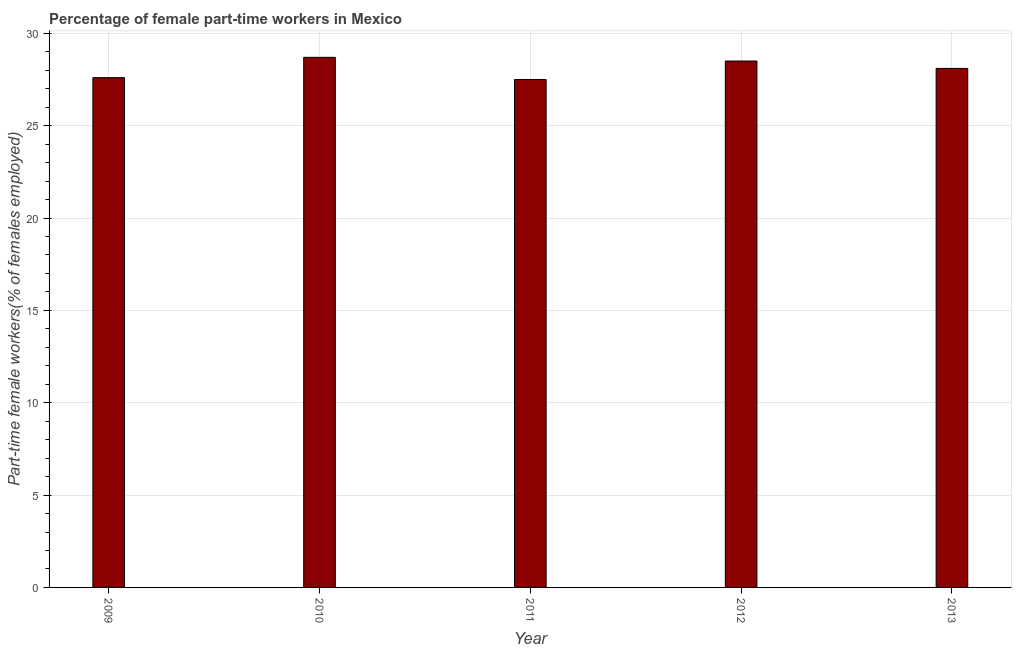Does the graph contain any zero values?
Ensure brevity in your answer.  No. What is the title of the graph?
Provide a short and direct response. Percentage of female part-time workers in Mexico. What is the label or title of the X-axis?
Ensure brevity in your answer.  Year. What is the label or title of the Y-axis?
Give a very brief answer. Part-time female workers(% of females employed). Across all years, what is the maximum percentage of part-time female workers?
Your response must be concise. 28.7. In which year was the percentage of part-time female workers maximum?
Your answer should be very brief. 2010. What is the sum of the percentage of part-time female workers?
Your response must be concise. 140.4. What is the average percentage of part-time female workers per year?
Make the answer very short. 28.08. What is the median percentage of part-time female workers?
Your response must be concise. 28.1. In how many years, is the percentage of part-time female workers greater than 29 %?
Your answer should be very brief. 0. Do a majority of the years between 2009 and 2012 (inclusive) have percentage of part-time female workers greater than 9 %?
Offer a very short reply. Yes. What is the difference between the highest and the lowest percentage of part-time female workers?
Provide a short and direct response. 1.2. How many bars are there?
Ensure brevity in your answer.  5. What is the Part-time female workers(% of females employed) of 2009?
Provide a succinct answer. 27.6. What is the Part-time female workers(% of females employed) of 2010?
Your response must be concise. 28.7. What is the Part-time female workers(% of females employed) in 2012?
Make the answer very short. 28.5. What is the Part-time female workers(% of females employed) of 2013?
Offer a terse response. 28.1. What is the difference between the Part-time female workers(% of females employed) in 2009 and 2010?
Offer a terse response. -1.1. What is the difference between the Part-time female workers(% of females employed) in 2009 and 2013?
Your response must be concise. -0.5. What is the difference between the Part-time female workers(% of females employed) in 2010 and 2011?
Offer a terse response. 1.2. What is the difference between the Part-time female workers(% of females employed) in 2010 and 2012?
Your response must be concise. 0.2. What is the difference between the Part-time female workers(% of females employed) in 2011 and 2012?
Offer a very short reply. -1. What is the difference between the Part-time female workers(% of females employed) in 2012 and 2013?
Provide a succinct answer. 0.4. What is the ratio of the Part-time female workers(% of females employed) in 2009 to that in 2013?
Give a very brief answer. 0.98. What is the ratio of the Part-time female workers(% of females employed) in 2010 to that in 2011?
Your answer should be compact. 1.04. What is the ratio of the Part-time female workers(% of females employed) in 2010 to that in 2012?
Your answer should be very brief. 1.01. What is the ratio of the Part-time female workers(% of females employed) in 2011 to that in 2012?
Provide a succinct answer. 0.96. 